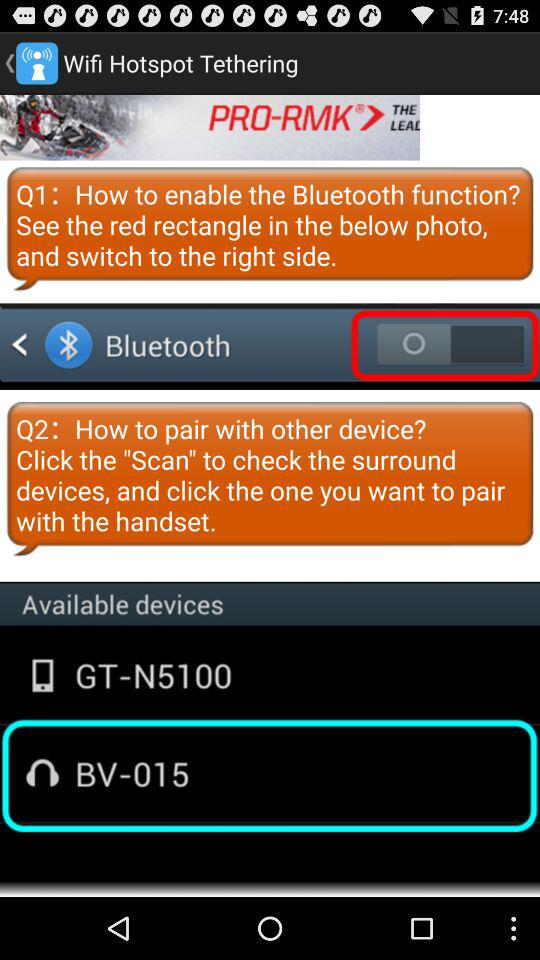What is the selected available device? The selected device is BV-015. 